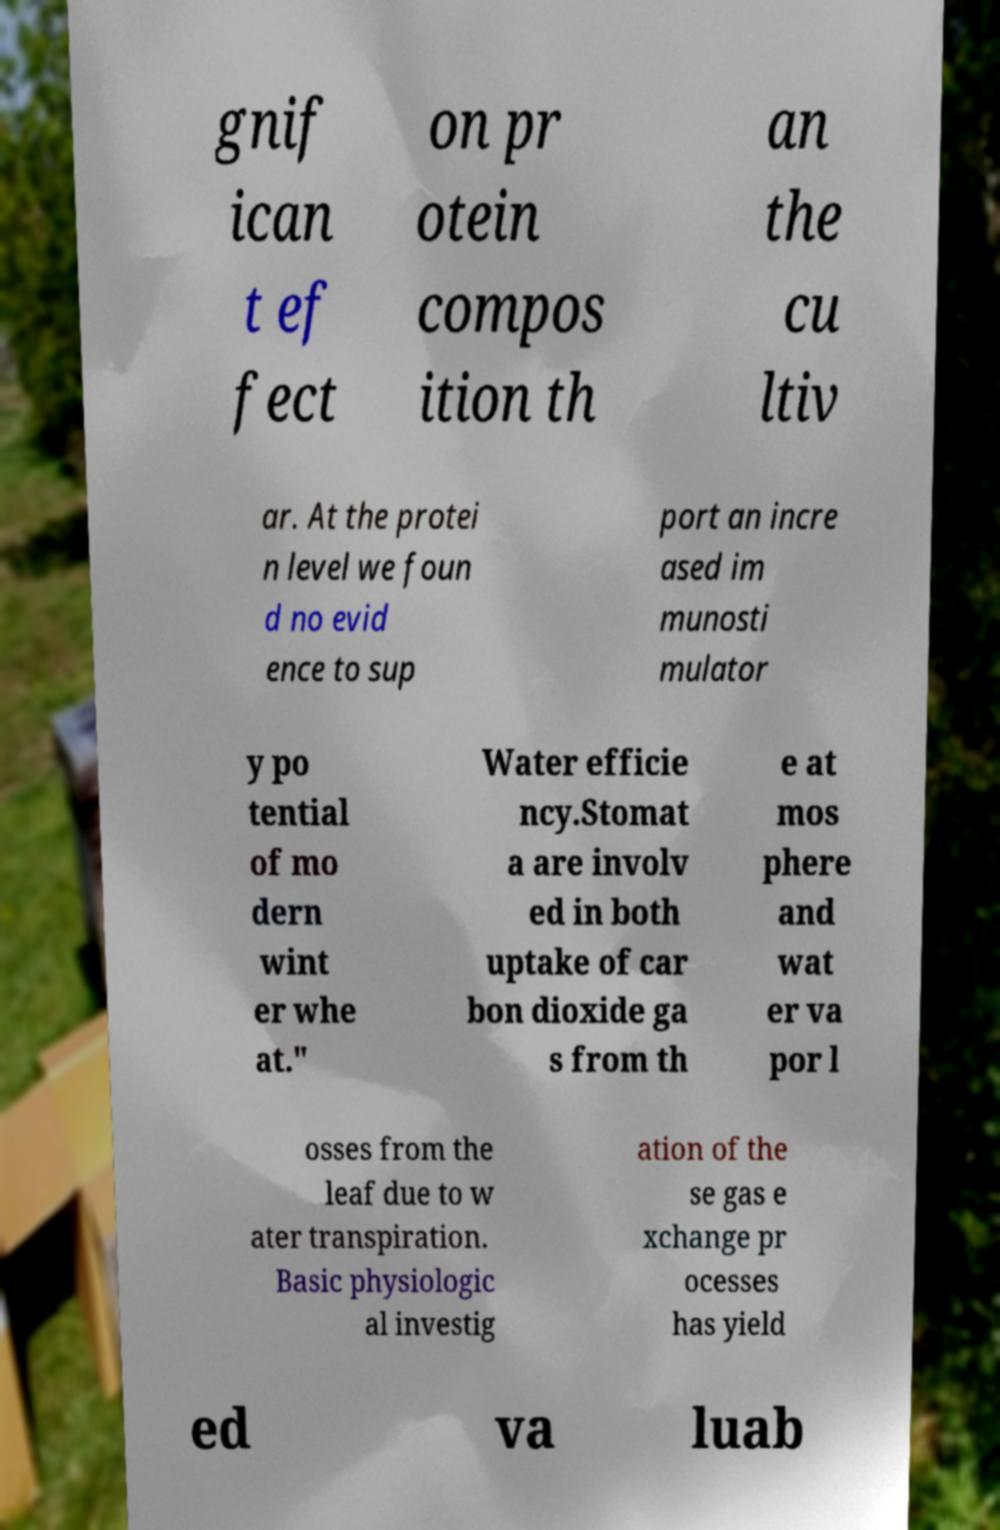There's text embedded in this image that I need extracted. Can you transcribe it verbatim? gnif ican t ef fect on pr otein compos ition th an the cu ltiv ar. At the protei n level we foun d no evid ence to sup port an incre ased im munosti mulator y po tential of mo dern wint er whe at." Water efficie ncy.Stomat a are involv ed in both uptake of car bon dioxide ga s from th e at mos phere and wat er va por l osses from the leaf due to w ater transpiration. Basic physiologic al investig ation of the se gas e xchange pr ocesses has yield ed va luab 